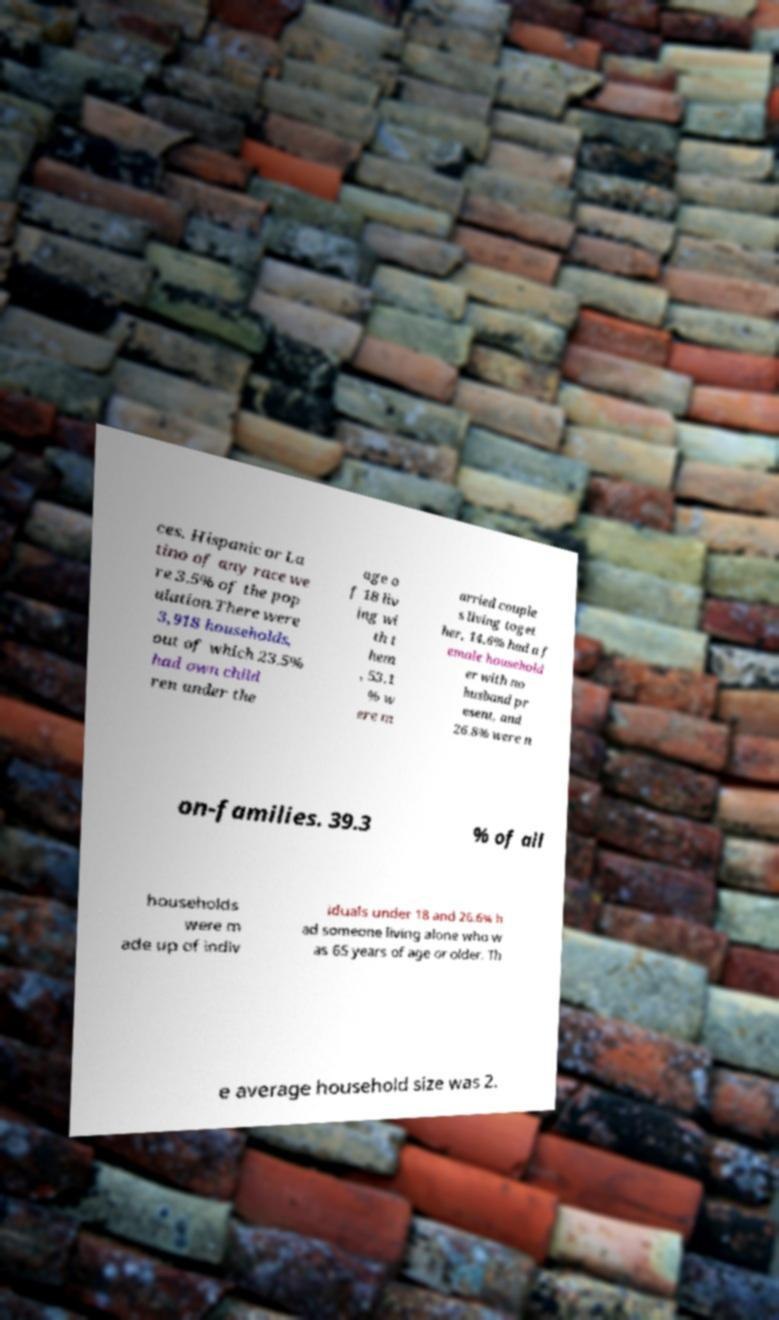Please read and relay the text visible in this image. What does it say? ces. Hispanic or La tino of any race we re 3.5% of the pop ulation.There were 3,918 households, out of which 23.5% had own child ren under the age o f 18 liv ing wi th t hem , 53.1 % w ere m arried couple s living toget her, 14.6% had a f emale household er with no husband pr esent, and 26.8% were n on-families. 39.3 % of all households were m ade up of indiv iduals under 18 and 26.6% h ad someone living alone who w as 65 years of age or older. Th e average household size was 2. 